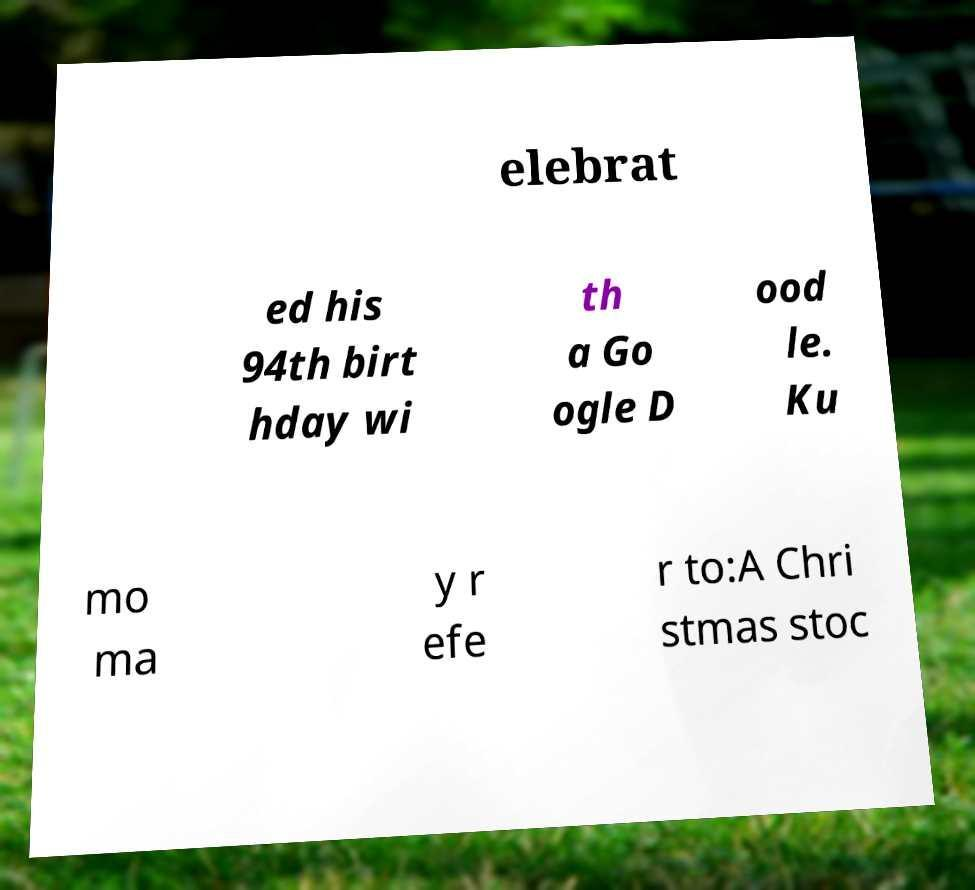Could you assist in decoding the text presented in this image and type it out clearly? elebrat ed his 94th birt hday wi th a Go ogle D ood le. Ku mo ma y r efe r to:A Chri stmas stoc 